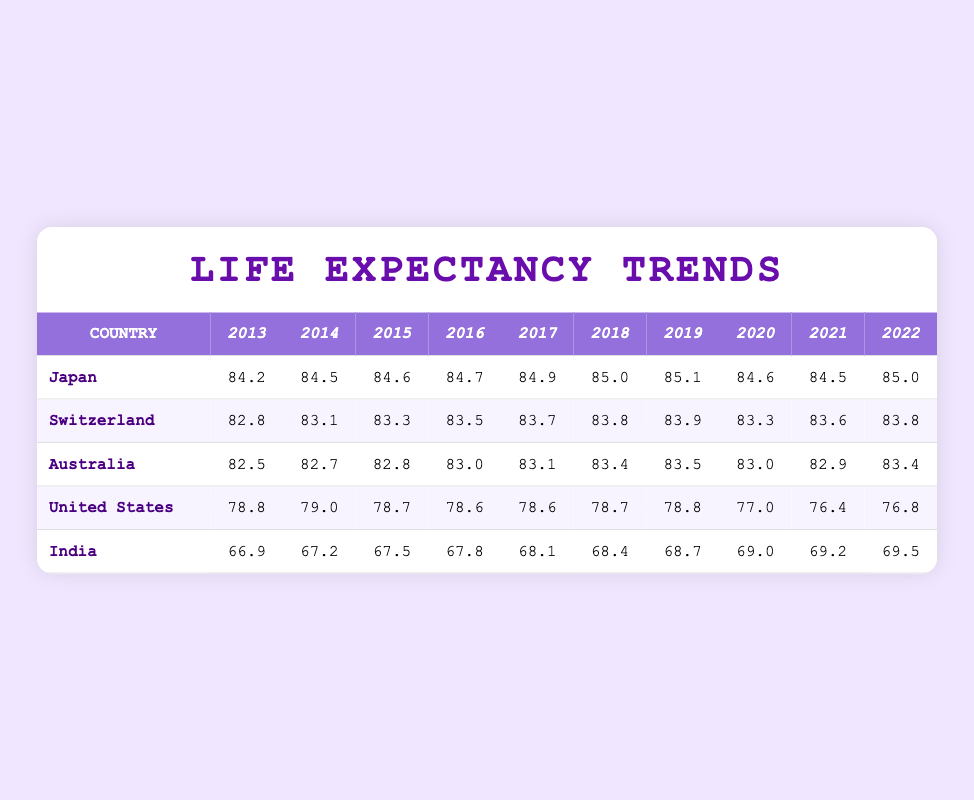What was the life expectancy in Japan in 2018? Looking at the row for Japan, the value for the year 2018 is found directly under that year, which is 85.0.
Answer: 85.0 What country had the lowest life expectancy in 2021? Checking the values for the year 2021 in all country rows, the United States has the lowest life expectancy at 76.4.
Answer: United States What is the average life expectancy in India over the last decade (2013-2022)? To find the average, add up the life expectancy values for India from 2013 to 2022: (66.9 + 67.2 + 67.5 + 67.8 + 68.1 + 68.4 + 68.7 + 69.0 + 69.2 + 69.5) = 683.3. Then divide by 10 (the number of years): 683.3 / 10 = 68.33.
Answer: 68.33 Did life expectancy in the United States improve from 2019 to 2022? Looking at the values for those years, in 2019 it was 78.8, and in 2022 it was 76.8. Since 76.8 is less than 78.8, it indicates a decrease in life expectancy.
Answer: No Which country experienced a rise in life expectancy every year from 2013 to 2019? By reviewing the figures, Japan shows an increase each year from 2013 to 2019: 84.2, 84.5, 84.6, 84.7, 84.9, 85.0, and 85.1. No other country shows a continuous rise during that period.
Answer: Japan What is the difference in life expectancy between Japan and Australia in 2022? In 2022, Japan's life expectancy is 85.0 and Australia's is 83.4. To find the difference, subtract Australia's value from Japan's: 85.0 - 83.4 = 1.6.
Answer: 1.6 Has life expectancy in Australia declined from 2019 to 2021? For Australia, the life expectancy was 83.5 in 2019 and dropped to 82.9 in 2021. Since 82.9 is less than 83.5, it indicates a decline.
Answer: Yes Which country had the highest average life expectancy from 2013 to 2022? To determine the highest, calculate the average for each country: Japan's average is 84.65, Switzerland's is 83.5, Australia’s is 83.1, the United States is 77.9, and India's is 68.33. Japan has the highest average.
Answer: Japan Did Switzerland's life expectancy remain above 82.5 from 2013 to 2022? By examining the values, Switzerland's life expectancy was above 82.5 for all years: it was 82.8 in 2013 and fluctuated but stayed above 82.5, finishing at 83.8 in 2022.
Answer: Yes 